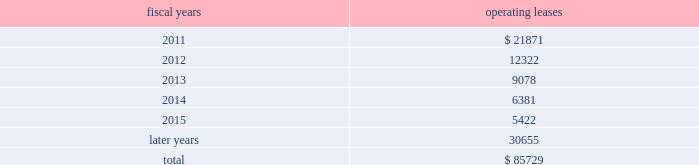The following is a schedule of future minimum rental payments required under long-term operating leases at october 30 , 2010 : fiscal years operating leases .
12 .
Commitments and contingencies from time to time in the ordinary course of the company 2019s business , various claims , charges and litigation are asserted or commenced against the company arising from , or related to , contractual matters , patents , trademarks , personal injury , environmental matters , product liability , insurance coverage and personnel and employment disputes .
As to such claims and litigation , the company can give no assurance that it will prevail .
The company does not believe that any current legal matters will have a material adverse effect on the company 2019s financial position , results of operations or cash flows .
13 .
Retirement plans the company and its subsidiaries have various savings and retirement plans covering substantially all employees .
The company maintains a defined contribution plan for the benefit of its eligible u.s .
Employees .
This plan provides for company contributions of up to 5% ( 5 % ) of each participant 2019s total eligible compensation .
In addition , the company contributes an amount equal to each participant 2019s pre-tax contribution , if any , up to a maximum of 3% ( 3 % ) of each participant 2019s total eligible compensation .
The total expense related to the defined contribution plan for u.s .
Employees was $ 20.5 million in fiscal 2010 , $ 21.5 million in fiscal 2009 and $ 22.6 million in fiscal 2008 .
The company also has various defined benefit pension and other retirement plans for certain non-u.s .
Employees that are consistent with local statutory requirements and practices .
The total expense related to the various defined benefit pension and other retirement plans for certain non-u.s .
Employees was $ 11.7 million in fiscal 2010 , $ 10.9 million in fiscal 2009 and $ 13.9 million in fiscal 2008 .
During fiscal 2009 , the measurement date of the plan 2019s funded status was changed from september 30 to the company 2019s fiscal year end .
Non-u.s .
Plan disclosures the company 2019s funding policy for its foreign defined benefit pension plans is consistent with the local requirements of each country .
The plans 2019 assets consist primarily of u.s .
And non-u.s .
Equity securities , bonds , property and cash .
The benefit obligations and related assets under these plans have been measured at october 30 , 2010 and october 31 , 2009 .
Analog devices , inc .
Notes to consolidated financial statements 2014 ( continued ) .
What was the average percentage that the lease expenses decreased from 2011 to 2013? 
Rationale: in order to find the average percentage decrease for this 3 year period one must find the change in percent for each year . this is calculated by subtracting the initial expense by the expense for the next year and then dividing the answer by the initial expense . then one has to find the average for the years .
Computations: ((((12322 - 9078) / 12322) + ((21871 - 12322) / 21871)) / 2)
Answer: 0.34994. 